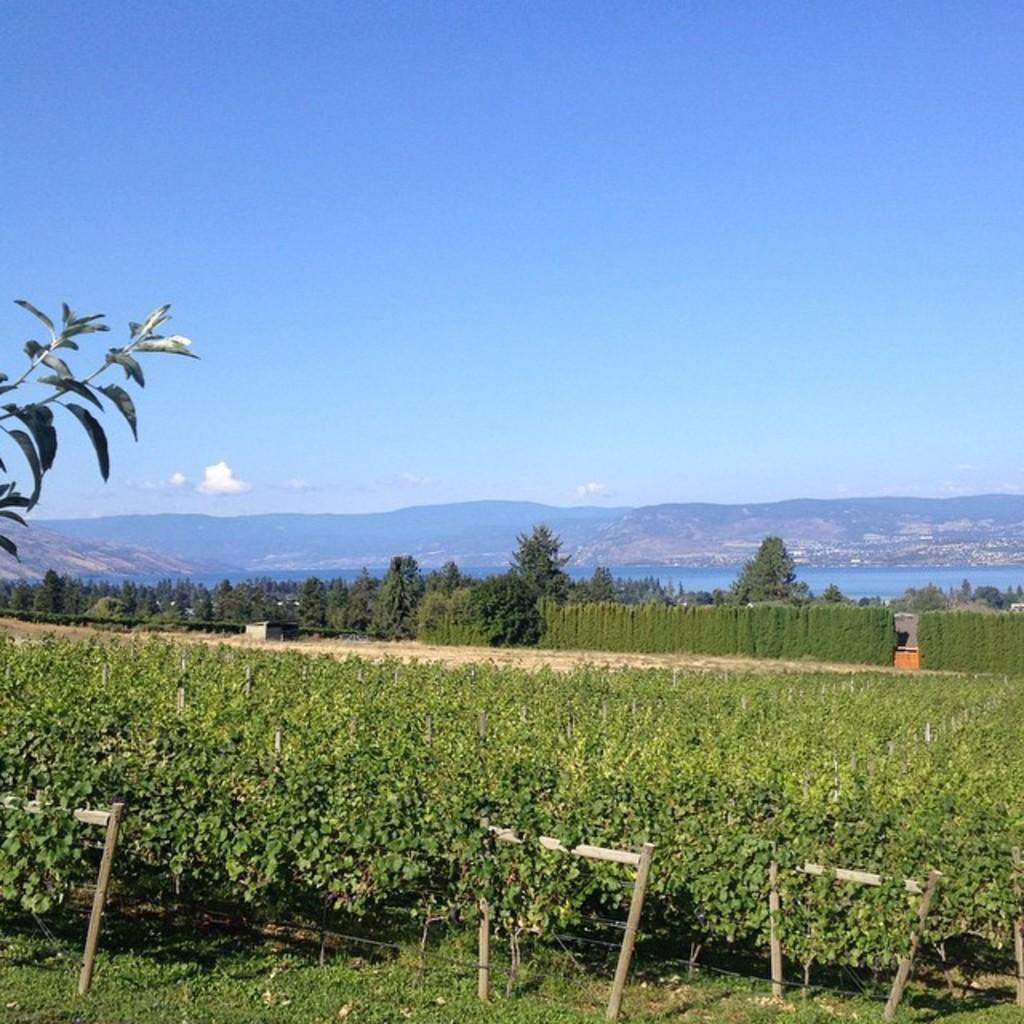What type of landscape is visible at the bottom of the image? There is a field at the bottom of the image. What can be seen in the background of the image? There are trees and mountains in the background of the image. What color is the sky in the image? The sky is blue at the top of the image. What is the purpose of the pear in the image? There is no pear present in the image, so it cannot serve any purpose. 